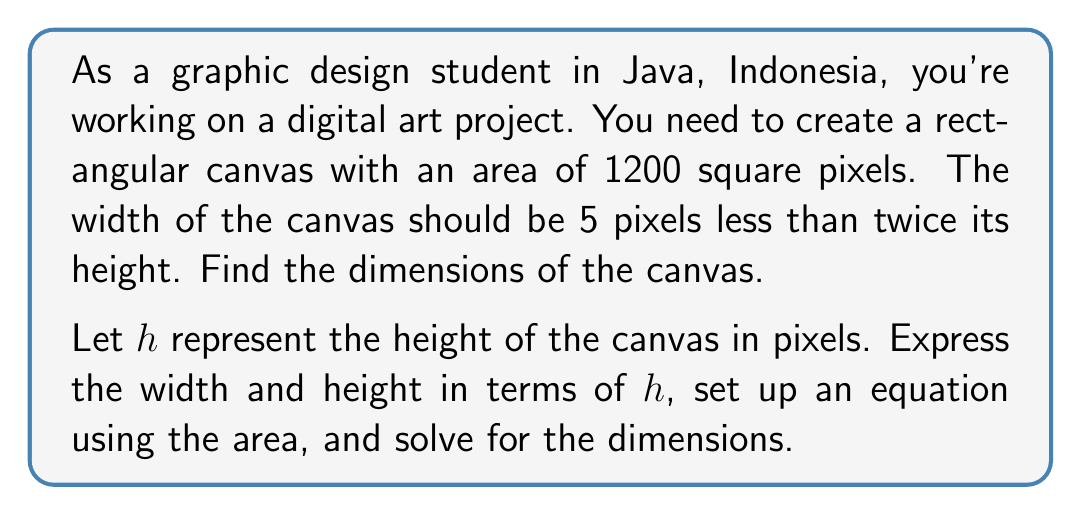Teach me how to tackle this problem. Let's approach this step-by-step:

1) Let $h$ = height of the canvas in pixels
   
2) The width is 5 pixels less than twice the height:
   Width = $2h - 5$

3) We know that Area = Width × Height
   Given area is 1200 square pixels

4) Set up the equation:
   $$(2h - 5) \times h = 1200$$

5) Expand the equation:
   $$2h^2 - 5h = 1200$$

6) Rearrange to standard form:
   $$2h^2 - 5h - 1200 = 0$$

7) This is a quadratic equation. We can solve it using the quadratic formula:
   $$h = \frac{-b \pm \sqrt{b^2 - 4ac}}{2a}$$
   Where $a = 2$, $b = -5$, and $c = -1200$

8) Substituting these values:
   $$h = \frac{5 \pm \sqrt{(-5)^2 - 4(2)(-1200)}}{2(2)}$$
   $$= \frac{5 \pm \sqrt{25 + 9600}}{4}$$
   $$= \frac{5 \pm \sqrt{9625}}{4}$$
   $$= \frac{5 \pm 98.108}{4}$$

9) This gives us two solutions:
   $$h = \frac{5 + 98.108}{4} \approx 25.777$$
   $$h = \frac{5 - 98.108}{4} \approx -23.277$$

10) Since height can't be negative, we take the positive solution:
    $h \approx 25.777$

11) Round to the nearest whole pixel: $h = 26$ pixels

12) Calculate the width:
    Width = $2h - 5 = 2(26) - 5 = 47$ pixels

Therefore, the dimensions of the canvas are 47 pixels wide by 26 pixels high.
Answer: The canvas dimensions are 47 pixels wide by 26 pixels high. 